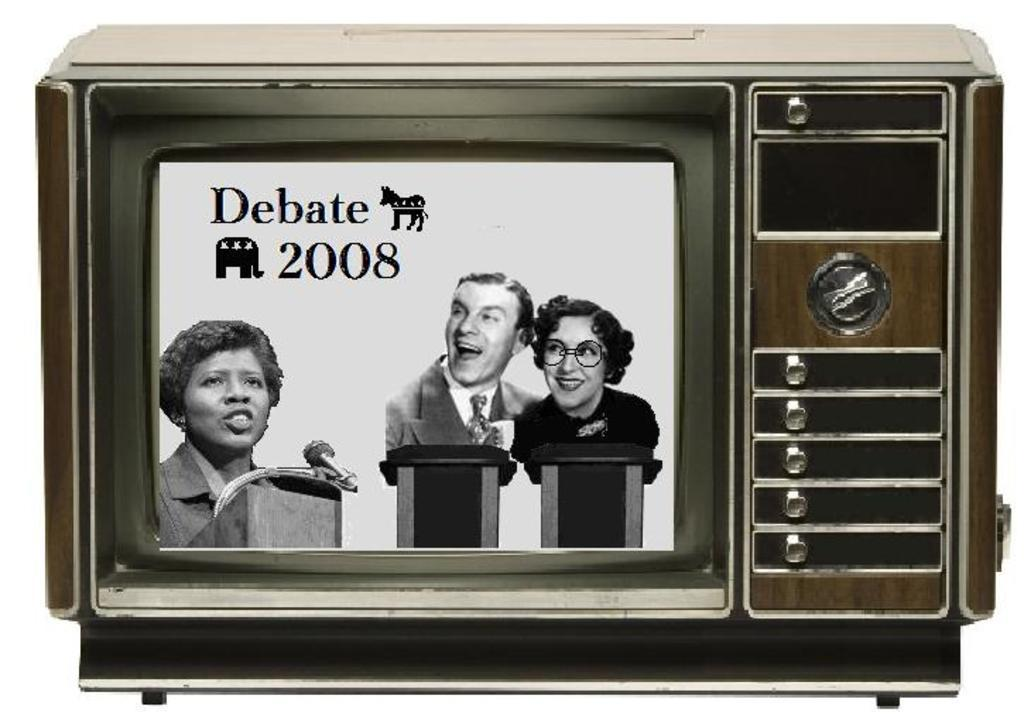<image>
Create a compact narrative representing the image presented. A TV screen mock up displays a Debate 2008 screen. 